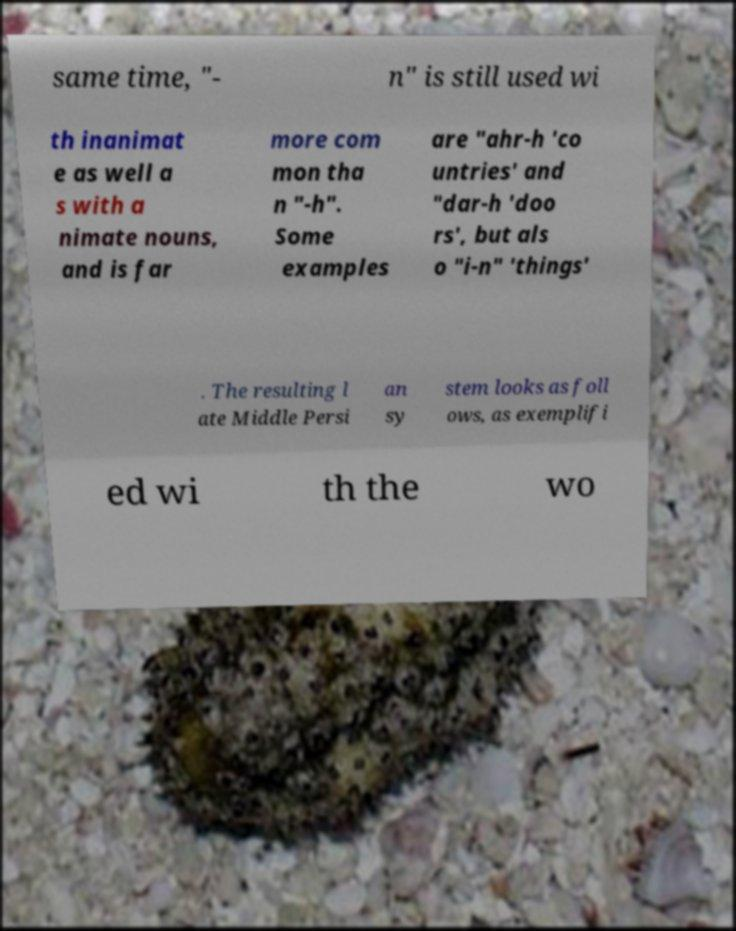What messages or text are displayed in this image? I need them in a readable, typed format. same time, "- n" is still used wi th inanimat e as well a s with a nimate nouns, and is far more com mon tha n "-h". Some examples are "ahr-h 'co untries' and "dar-h 'doo rs', but als o "i-n" 'things' . The resulting l ate Middle Persi an sy stem looks as foll ows, as exemplifi ed wi th the wo 